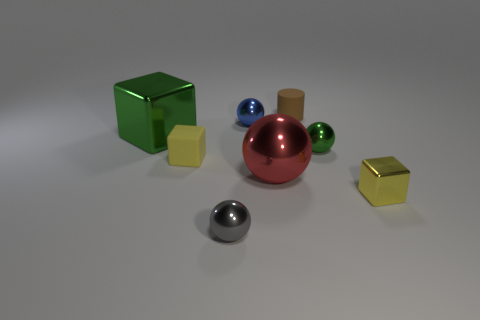There is a thing that is the same color as the matte block; what material is it?
Give a very brief answer. Metal. The object that is to the left of the gray shiny sphere and behind the small yellow rubber block has what shape?
Offer a terse response. Cube. What is the tiny yellow cube that is in front of the big object to the right of the large metal thing left of the large red ball made of?
Offer a very short reply. Metal. There is a object that is the same color as the tiny metal block; what size is it?
Offer a terse response. Small. What is the big green thing made of?
Offer a terse response. Metal. Is the material of the red ball the same as the small yellow object to the left of the gray metallic object?
Ensure brevity in your answer.  No. There is a tiny rubber thing in front of the small rubber thing that is behind the rubber cube; what is its color?
Your response must be concise. Yellow. There is a object that is both in front of the red thing and on the right side of the small brown rubber cylinder; what size is it?
Your answer should be compact. Small. What number of other objects are the same shape as the tiny yellow metal object?
Give a very brief answer. 2. Is the shape of the big green thing the same as the metal object that is behind the large metallic cube?
Provide a succinct answer. No. 